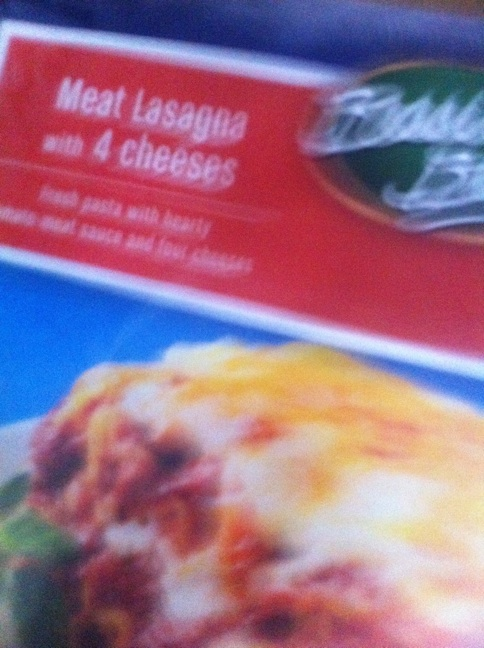What brand of lasagna is this and if you can see it what are the instructions? The image shows a box of 'Freschetta' brand Meat Lasagna with 4 cheeses. Unfortunately, the specific cooking instructions are not clearly visible in the image provided. 